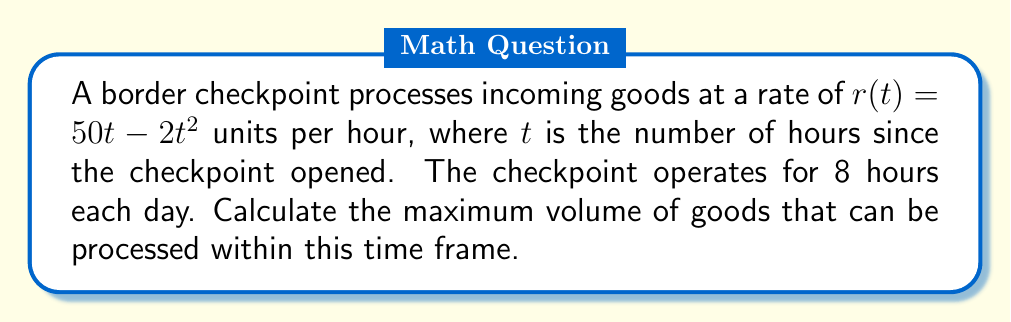Provide a solution to this math problem. To solve this problem, we need to follow these steps:

1) First, we need to find the total volume of goods processed over the 8-hour period. This is given by the definite integral of the rate function from 0 to 8:

   $$V = \int_0^8 (50t - 2t^2) dt$$

2) To evaluate this integral:
   $$V = \left[50\frac{t^2}{2} - 2\frac{t^3}{3}\right]_0^8$$

3) Substituting the limits:
   $$V = \left(50\frac{8^2}{2} - 2\frac{8^3}{3}\right) - \left(50\frac{0^2}{2} - 2\frac{0^3}{3}\right)$$

4) Simplifying:
   $$V = (1600 - 341.33) - 0 = 1258.67$$

5) Therefore, the maximum volume of goods that can be processed within the 8-hour time frame is approximately 1259 units.
Answer: The maximum volume of goods that can be processed within the 8-hour time frame is approximately 1259 units. 